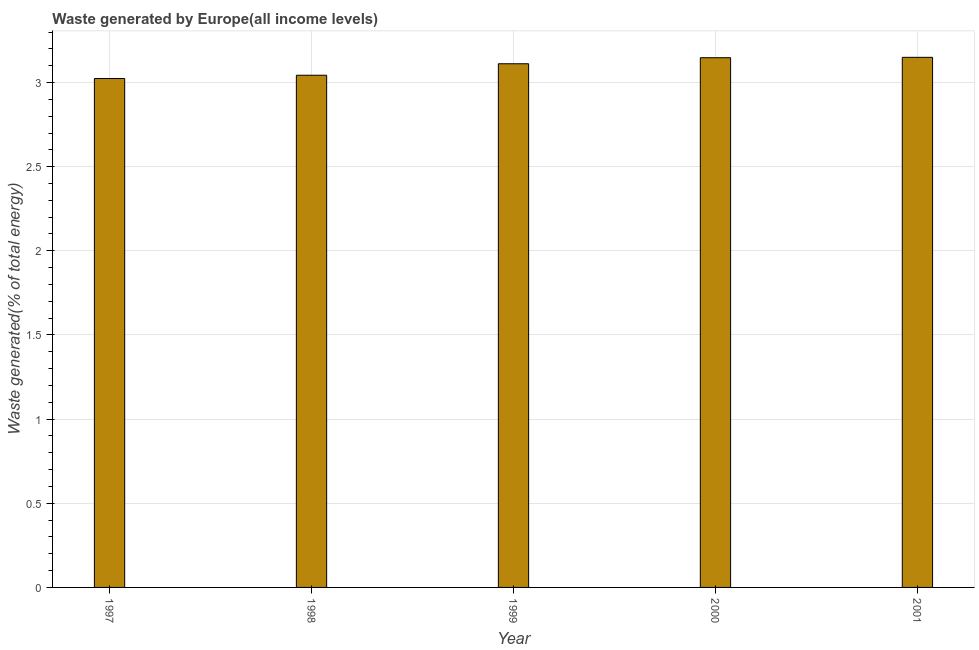Does the graph contain grids?
Your response must be concise. Yes. What is the title of the graph?
Your response must be concise. Waste generated by Europe(all income levels). What is the label or title of the X-axis?
Keep it short and to the point. Year. What is the label or title of the Y-axis?
Make the answer very short. Waste generated(% of total energy). What is the amount of waste generated in 1999?
Offer a terse response. 3.11. Across all years, what is the maximum amount of waste generated?
Make the answer very short. 3.15. Across all years, what is the minimum amount of waste generated?
Your answer should be compact. 3.02. In which year was the amount of waste generated minimum?
Offer a terse response. 1997. What is the sum of the amount of waste generated?
Provide a succinct answer. 15.48. What is the difference between the amount of waste generated in 1998 and 1999?
Provide a succinct answer. -0.07. What is the average amount of waste generated per year?
Keep it short and to the point. 3.1. What is the median amount of waste generated?
Provide a short and direct response. 3.11. What is the ratio of the amount of waste generated in 1997 to that in 1998?
Your answer should be very brief. 0.99. Is the difference between the amount of waste generated in 1998 and 1999 greater than the difference between any two years?
Keep it short and to the point. No. What is the difference between the highest and the second highest amount of waste generated?
Make the answer very short. 0. What is the difference between the highest and the lowest amount of waste generated?
Offer a terse response. 0.13. In how many years, is the amount of waste generated greater than the average amount of waste generated taken over all years?
Keep it short and to the point. 3. How many bars are there?
Provide a succinct answer. 5. What is the Waste generated(% of total energy) of 1997?
Ensure brevity in your answer.  3.02. What is the Waste generated(% of total energy) of 1998?
Provide a succinct answer. 3.04. What is the Waste generated(% of total energy) of 1999?
Offer a terse response. 3.11. What is the Waste generated(% of total energy) of 2000?
Your answer should be compact. 3.15. What is the Waste generated(% of total energy) of 2001?
Your answer should be compact. 3.15. What is the difference between the Waste generated(% of total energy) in 1997 and 1998?
Your answer should be very brief. -0.02. What is the difference between the Waste generated(% of total energy) in 1997 and 1999?
Make the answer very short. -0.09. What is the difference between the Waste generated(% of total energy) in 1997 and 2000?
Make the answer very short. -0.12. What is the difference between the Waste generated(% of total energy) in 1997 and 2001?
Offer a terse response. -0.13. What is the difference between the Waste generated(% of total energy) in 1998 and 1999?
Your response must be concise. -0.07. What is the difference between the Waste generated(% of total energy) in 1998 and 2000?
Offer a terse response. -0.1. What is the difference between the Waste generated(% of total energy) in 1998 and 2001?
Your answer should be very brief. -0.11. What is the difference between the Waste generated(% of total energy) in 1999 and 2000?
Provide a succinct answer. -0.04. What is the difference between the Waste generated(% of total energy) in 1999 and 2001?
Offer a terse response. -0.04. What is the difference between the Waste generated(% of total energy) in 2000 and 2001?
Offer a very short reply. -0. What is the ratio of the Waste generated(% of total energy) in 1997 to that in 1998?
Your answer should be compact. 0.99. What is the ratio of the Waste generated(% of total energy) in 1997 to that in 1999?
Keep it short and to the point. 0.97. What is the ratio of the Waste generated(% of total energy) in 1997 to that in 2001?
Your answer should be very brief. 0.96. What is the ratio of the Waste generated(% of total energy) in 1998 to that in 2001?
Your answer should be very brief. 0.97. What is the ratio of the Waste generated(% of total energy) in 1999 to that in 2001?
Provide a succinct answer. 0.99. 